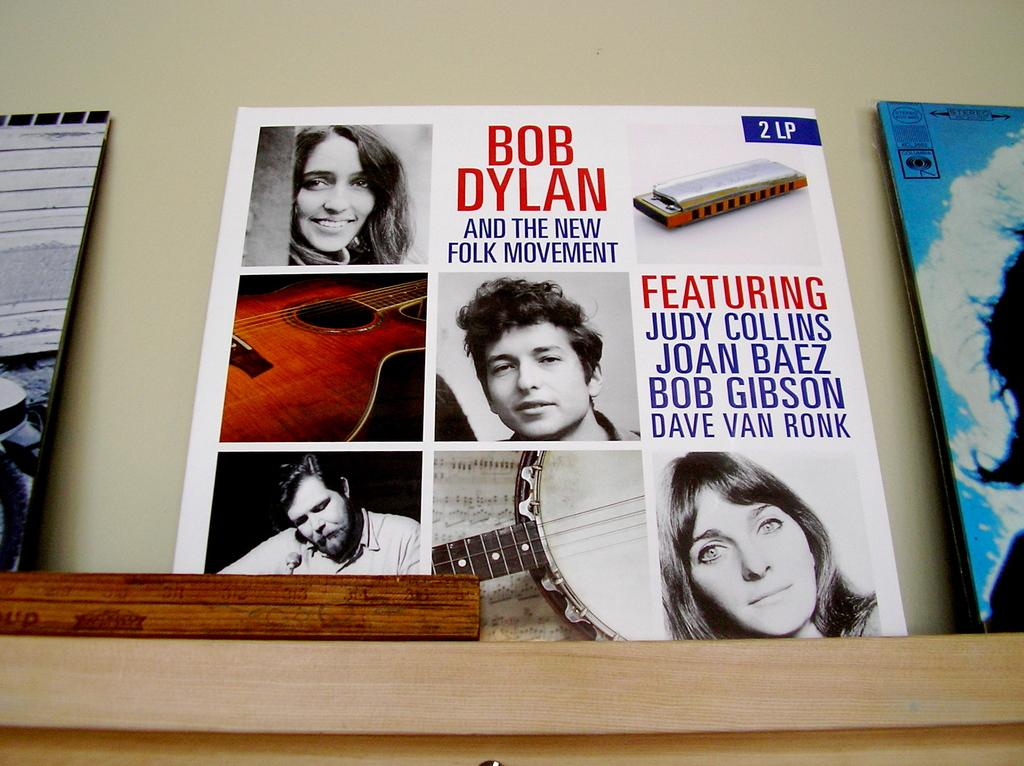<image>
Give a short and clear explanation of the subsequent image. A Bob Dylan record says it features Judy Collins. 